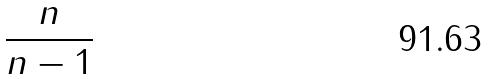Convert formula to latex. <formula><loc_0><loc_0><loc_500><loc_500>\frac { n } { n - 1 }</formula> 